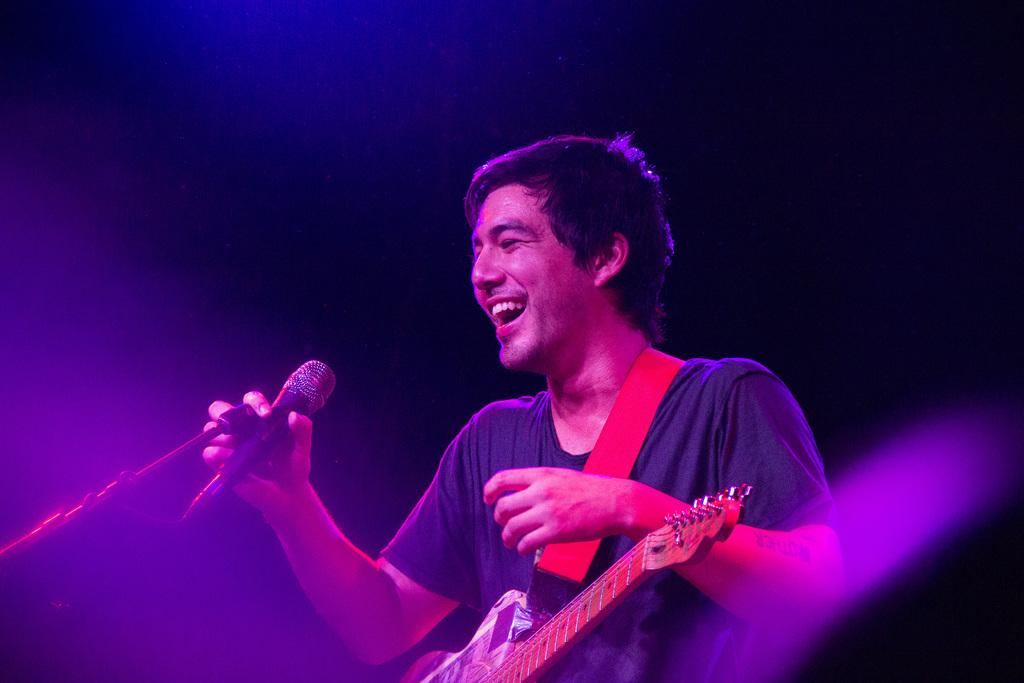What is the main subject of the image? The main subject of the image is a man. What is the man doing in the image? The man is standing on the floor and holding a microphone. What instrument is the man associated with in the image? The man has a guitar across his shoulders. What is the man's facial expression in the image? The man is smiling in the image. What type of polish is the man applying to his foot in the image? There is no indication in the image that the man is applying polish to his foot, as he is holding a microphone and a guitar. 